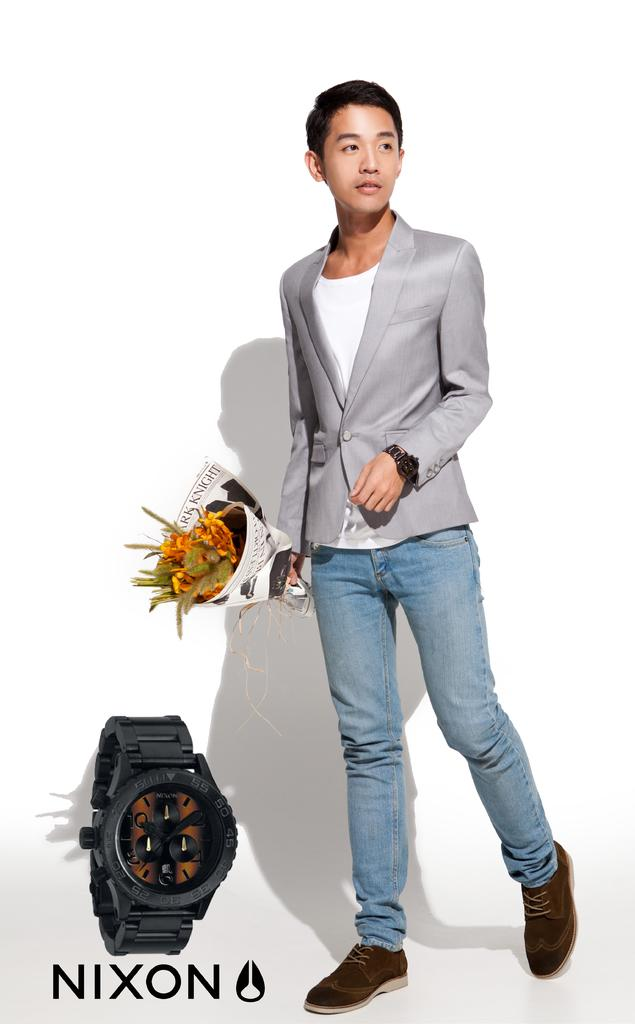Provide a one-sentence caption for the provided image. Advertisement for Nixon watch featuring man in blazer and jeans holding flowers, with watch at lower left corner. 